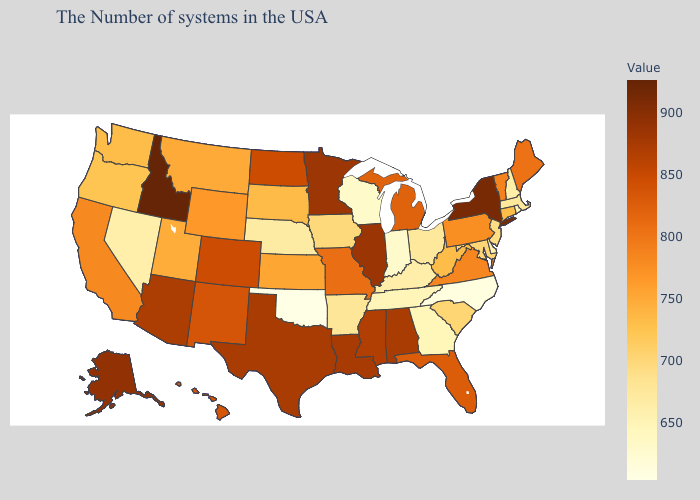Which states have the highest value in the USA?
Be succinct. Idaho. Does Idaho have the highest value in the USA?
Short answer required. Yes. Which states have the lowest value in the West?
Answer briefly. Nevada. Does the map have missing data?
Quick response, please. No. Does California have a lower value than South Dakota?
Write a very short answer. No. 